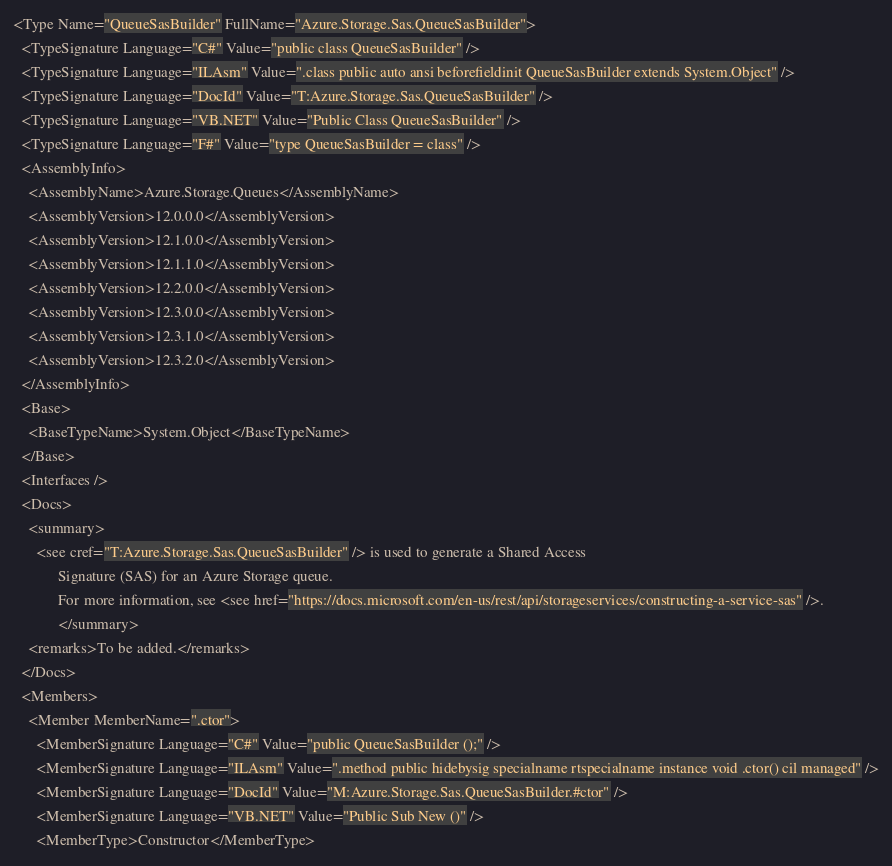<code> <loc_0><loc_0><loc_500><loc_500><_XML_><Type Name="QueueSasBuilder" FullName="Azure.Storage.Sas.QueueSasBuilder">
  <TypeSignature Language="C#" Value="public class QueueSasBuilder" />
  <TypeSignature Language="ILAsm" Value=".class public auto ansi beforefieldinit QueueSasBuilder extends System.Object" />
  <TypeSignature Language="DocId" Value="T:Azure.Storage.Sas.QueueSasBuilder" />
  <TypeSignature Language="VB.NET" Value="Public Class QueueSasBuilder" />
  <TypeSignature Language="F#" Value="type QueueSasBuilder = class" />
  <AssemblyInfo>
    <AssemblyName>Azure.Storage.Queues</AssemblyName>
    <AssemblyVersion>12.0.0.0</AssemblyVersion>
    <AssemblyVersion>12.1.0.0</AssemblyVersion>
    <AssemblyVersion>12.1.1.0</AssemblyVersion>
    <AssemblyVersion>12.2.0.0</AssemblyVersion>
    <AssemblyVersion>12.3.0.0</AssemblyVersion>
    <AssemblyVersion>12.3.1.0</AssemblyVersion>
    <AssemblyVersion>12.3.2.0</AssemblyVersion>
  </AssemblyInfo>
  <Base>
    <BaseTypeName>System.Object</BaseTypeName>
  </Base>
  <Interfaces />
  <Docs>
    <summary>
      <see cref="T:Azure.Storage.Sas.QueueSasBuilder" /> is used to generate a Shared Access
            Signature (SAS) for an Azure Storage queue.
            For more information, see <see href="https://docs.microsoft.com/en-us/rest/api/storageservices/constructing-a-service-sas" />.
            </summary>
    <remarks>To be added.</remarks>
  </Docs>
  <Members>
    <Member MemberName=".ctor">
      <MemberSignature Language="C#" Value="public QueueSasBuilder ();" />
      <MemberSignature Language="ILAsm" Value=".method public hidebysig specialname rtspecialname instance void .ctor() cil managed" />
      <MemberSignature Language="DocId" Value="M:Azure.Storage.Sas.QueueSasBuilder.#ctor" />
      <MemberSignature Language="VB.NET" Value="Public Sub New ()" />
      <MemberType>Constructor</MemberType></code> 